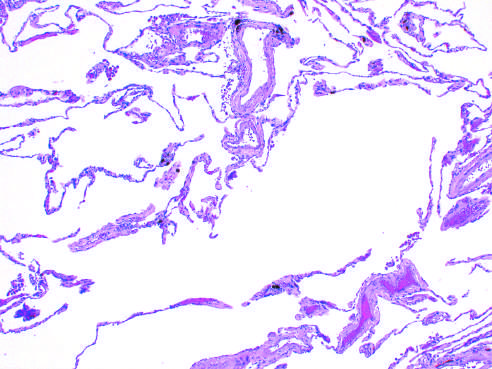s the healing stage marked enlargement of the air spaces, with destruction of alveolar septa but without fibrosis?
Answer the question using a single word or phrase. No 